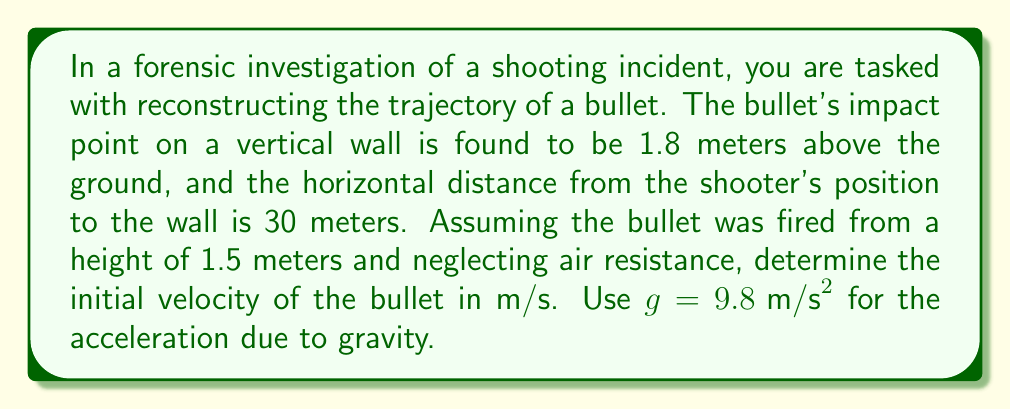Could you help me with this problem? Let's approach this step-by-step:

1) We can use the equations of motion for projectile motion. The relevant equations are:

   $$y = y_0 + v_0y t - \frac{1}{2}gt^2$$
   $$x = v_0x t$$

   Where $y$ is the vertical position, $y_0$ is the initial height, $v_0y$ is the initial vertical velocity, $t$ is time, $g$ is acceleration due to gravity, $x$ is the horizontal distance, and $v_0x$ is the initial horizontal velocity.

2) We know:
   - $y = 1.8 \text{ m}$ (final height)
   - $y_0 = 1.5 \text{ m}$ (initial height)
   - $x = 30 \text{ m}$ (horizontal distance)
   - $g = 9.8 \text{ m/s}^2$

3) From the horizontal motion equation, we can find the time of flight:

   $$t = \frac{x}{v_0x}$$

4) Substituting this into the vertical motion equation:

   $$1.8 = 1.5 + v_0y (\frac{30}{v_0x}) - \frac{1}{2}(9.8)(\frac{30}{v_0x})^2$$

5) We can simplify this by noting that $v_0y = v_0 \sin \theta$ and $v_0x = v_0 \cos \theta$, where $v_0$ is the initial velocity and $\theta$ is the launch angle. Substituting:

   $$0.3 = 30 \tan \theta - \frac{9.8 \cdot 900}{2v_0^2 \cos^2 \theta}$$

6) This equation has two unknowns: $v_0$ and $\theta$. We need another equation. We can use the range equation:

   $$30 = \frac{v_0^2 \sin 2\theta}{g}$$

7) From this, we can express $\sin 2\theta$ in terms of $v_0$:

   $$\sin 2\theta = \frac{30g}{v_0^2}$$

8) Using the identity $\tan \theta = \frac{\sin \theta}{\cos \theta}$ and $\sin 2\theta = 2\sin \theta \cos \theta$, we can derive:

   $$\tan \theta = \frac{15g}{v_0^2}$$

9) Substituting this back into the equation from step 5:

   $$0.3 = 30 (\frac{15g}{v_0^2}) - \frac{9.8 \cdot 900}{2v_0^2 (1 + (\frac{15g}{v_0^2})^2)}$$

10) This equation can be solved numerically for $v_0$, yielding approximately 153.4 m/s.
Answer: $153.4 \text{ m/s}$ 